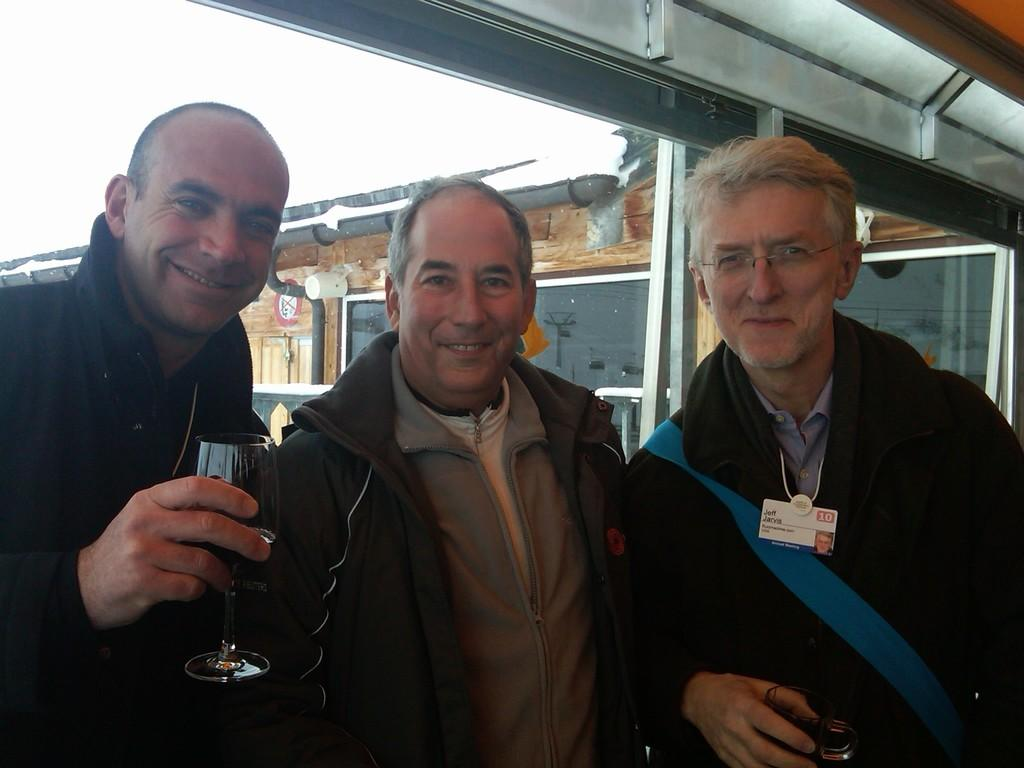How many people are in the image? There are three men in the image. What is the facial expression of the men in the image? The men are smiling. What type of clothing are the men wearing? The men are wearing coats. What can be seen in the background of the image? There is a house in the background of the image. What direction are the men flying in the image? There is no indication that the men are flying in the image; they are standing on the ground. 